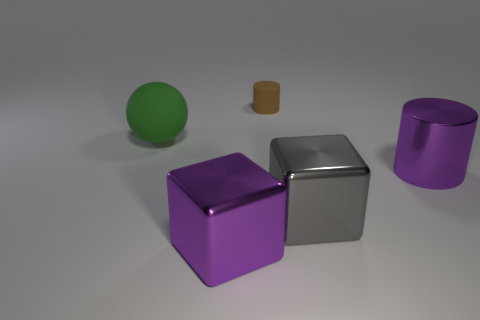Add 3 green spheres. How many objects exist? 8 Subtract all cylinders. How many objects are left? 3 Subtract all cyan metal blocks. Subtract all gray objects. How many objects are left? 4 Add 3 big purple metal cubes. How many big purple metal cubes are left? 4 Add 4 small green matte balls. How many small green matte balls exist? 4 Subtract 0 purple spheres. How many objects are left? 5 